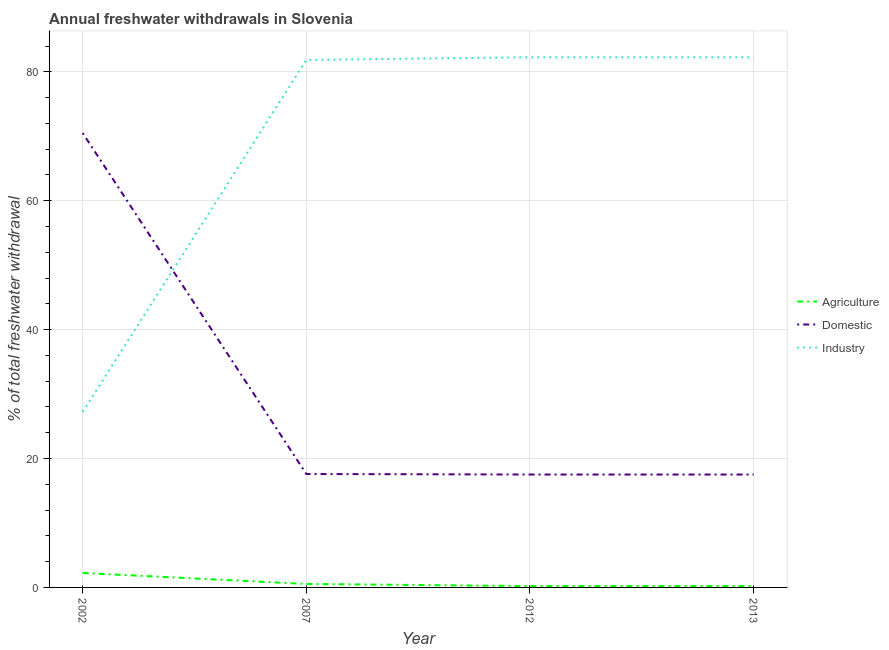Does the line corresponding to percentage of freshwater withdrawal for domestic purposes intersect with the line corresponding to percentage of freshwater withdrawal for industry?
Ensure brevity in your answer.  Yes. Is the number of lines equal to the number of legend labels?
Keep it short and to the point. Yes. What is the percentage of freshwater withdrawal for industry in 2007?
Ensure brevity in your answer.  81.86. Across all years, what is the maximum percentage of freshwater withdrawal for agriculture?
Make the answer very short. 2.24. Across all years, what is the minimum percentage of freshwater withdrawal for industry?
Keep it short and to the point. 27.24. In which year was the percentage of freshwater withdrawal for industry maximum?
Your answer should be very brief. 2012. In which year was the percentage of freshwater withdrawal for agriculture minimum?
Offer a very short reply. 2012. What is the total percentage of freshwater withdrawal for agriculture in the graph?
Your answer should be compact. 3.21. What is the difference between the percentage of freshwater withdrawal for agriculture in 2002 and that in 2013?
Your response must be concise. 2.03. What is the difference between the percentage of freshwater withdrawal for agriculture in 2012 and the percentage of freshwater withdrawal for domestic purposes in 2007?
Give a very brief answer. -17.39. What is the average percentage of freshwater withdrawal for industry per year?
Your response must be concise. 68.41. In the year 2012, what is the difference between the percentage of freshwater withdrawal for agriculture and percentage of freshwater withdrawal for domestic purposes?
Provide a short and direct response. -17.31. What is the ratio of the percentage of freshwater withdrawal for domestic purposes in 2002 to that in 2013?
Offer a very short reply. 4.02. Is the percentage of freshwater withdrawal for industry in 2007 less than that in 2012?
Your answer should be very brief. Yes. Is the difference between the percentage of freshwater withdrawal for domestic purposes in 2002 and 2007 greater than the difference between the percentage of freshwater withdrawal for agriculture in 2002 and 2007?
Your answer should be compact. Yes. What is the difference between the highest and the second highest percentage of freshwater withdrawal for industry?
Offer a terse response. 0. What is the difference between the highest and the lowest percentage of freshwater withdrawal for agriculture?
Offer a very short reply. 2.03. Is the percentage of freshwater withdrawal for agriculture strictly less than the percentage of freshwater withdrawal for domestic purposes over the years?
Your answer should be compact. Yes. How many lines are there?
Give a very brief answer. 3. How many years are there in the graph?
Offer a very short reply. 4. Are the values on the major ticks of Y-axis written in scientific E-notation?
Your answer should be compact. No. Where does the legend appear in the graph?
Offer a very short reply. Center right. How are the legend labels stacked?
Keep it short and to the point. Vertical. What is the title of the graph?
Your answer should be compact. Annual freshwater withdrawals in Slovenia. Does "Poland" appear as one of the legend labels in the graph?
Ensure brevity in your answer.  No. What is the label or title of the Y-axis?
Ensure brevity in your answer.  % of total freshwater withdrawal. What is the % of total freshwater withdrawal of Agriculture in 2002?
Your answer should be compact. 2.24. What is the % of total freshwater withdrawal in Domestic in 2002?
Your answer should be compact. 70.51. What is the % of total freshwater withdrawal in Industry in 2002?
Ensure brevity in your answer.  27.24. What is the % of total freshwater withdrawal in Agriculture in 2007?
Give a very brief answer. 0.54. What is the % of total freshwater withdrawal of Industry in 2007?
Ensure brevity in your answer.  81.86. What is the % of total freshwater withdrawal in Agriculture in 2012?
Provide a short and direct response. 0.21. What is the % of total freshwater withdrawal in Domestic in 2012?
Your answer should be compact. 17.52. What is the % of total freshwater withdrawal in Industry in 2012?
Provide a short and direct response. 82.27. What is the % of total freshwater withdrawal of Agriculture in 2013?
Provide a short and direct response. 0.21. What is the % of total freshwater withdrawal of Domestic in 2013?
Offer a very short reply. 17.52. What is the % of total freshwater withdrawal of Industry in 2013?
Your response must be concise. 82.27. Across all years, what is the maximum % of total freshwater withdrawal in Agriculture?
Keep it short and to the point. 2.24. Across all years, what is the maximum % of total freshwater withdrawal in Domestic?
Your answer should be very brief. 70.51. Across all years, what is the maximum % of total freshwater withdrawal of Industry?
Your answer should be very brief. 82.27. Across all years, what is the minimum % of total freshwater withdrawal in Agriculture?
Make the answer very short. 0.21. Across all years, what is the minimum % of total freshwater withdrawal in Domestic?
Ensure brevity in your answer.  17.52. Across all years, what is the minimum % of total freshwater withdrawal of Industry?
Provide a succinct answer. 27.24. What is the total % of total freshwater withdrawal in Agriculture in the graph?
Your answer should be very brief. 3.21. What is the total % of total freshwater withdrawal of Domestic in the graph?
Ensure brevity in your answer.  123.15. What is the total % of total freshwater withdrawal of Industry in the graph?
Offer a terse response. 273.64. What is the difference between the % of total freshwater withdrawal in Agriculture in 2002 and that in 2007?
Offer a terse response. 1.7. What is the difference between the % of total freshwater withdrawal of Domestic in 2002 and that in 2007?
Provide a succinct answer. 52.91. What is the difference between the % of total freshwater withdrawal in Industry in 2002 and that in 2007?
Ensure brevity in your answer.  -54.62. What is the difference between the % of total freshwater withdrawal in Agriculture in 2002 and that in 2012?
Ensure brevity in your answer.  2.03. What is the difference between the % of total freshwater withdrawal in Domestic in 2002 and that in 2012?
Your answer should be compact. 52.99. What is the difference between the % of total freshwater withdrawal in Industry in 2002 and that in 2012?
Your response must be concise. -55.03. What is the difference between the % of total freshwater withdrawal of Agriculture in 2002 and that in 2013?
Give a very brief answer. 2.03. What is the difference between the % of total freshwater withdrawal in Domestic in 2002 and that in 2013?
Keep it short and to the point. 52.99. What is the difference between the % of total freshwater withdrawal of Industry in 2002 and that in 2013?
Provide a short and direct response. -55.03. What is the difference between the % of total freshwater withdrawal of Agriculture in 2007 and that in 2012?
Offer a terse response. 0.33. What is the difference between the % of total freshwater withdrawal of Domestic in 2007 and that in 2012?
Your response must be concise. 0.08. What is the difference between the % of total freshwater withdrawal in Industry in 2007 and that in 2012?
Provide a short and direct response. -0.41. What is the difference between the % of total freshwater withdrawal in Agriculture in 2007 and that in 2013?
Give a very brief answer. 0.33. What is the difference between the % of total freshwater withdrawal in Industry in 2007 and that in 2013?
Ensure brevity in your answer.  -0.41. What is the difference between the % of total freshwater withdrawal in Industry in 2012 and that in 2013?
Your answer should be very brief. 0. What is the difference between the % of total freshwater withdrawal in Agriculture in 2002 and the % of total freshwater withdrawal in Domestic in 2007?
Provide a succinct answer. -15.36. What is the difference between the % of total freshwater withdrawal of Agriculture in 2002 and the % of total freshwater withdrawal of Industry in 2007?
Make the answer very short. -79.62. What is the difference between the % of total freshwater withdrawal in Domestic in 2002 and the % of total freshwater withdrawal in Industry in 2007?
Give a very brief answer. -11.35. What is the difference between the % of total freshwater withdrawal of Agriculture in 2002 and the % of total freshwater withdrawal of Domestic in 2012?
Keep it short and to the point. -15.28. What is the difference between the % of total freshwater withdrawal of Agriculture in 2002 and the % of total freshwater withdrawal of Industry in 2012?
Provide a succinct answer. -80.03. What is the difference between the % of total freshwater withdrawal of Domestic in 2002 and the % of total freshwater withdrawal of Industry in 2012?
Ensure brevity in your answer.  -11.76. What is the difference between the % of total freshwater withdrawal of Agriculture in 2002 and the % of total freshwater withdrawal of Domestic in 2013?
Your answer should be very brief. -15.28. What is the difference between the % of total freshwater withdrawal of Agriculture in 2002 and the % of total freshwater withdrawal of Industry in 2013?
Provide a succinct answer. -80.03. What is the difference between the % of total freshwater withdrawal of Domestic in 2002 and the % of total freshwater withdrawal of Industry in 2013?
Your response must be concise. -11.76. What is the difference between the % of total freshwater withdrawal in Agriculture in 2007 and the % of total freshwater withdrawal in Domestic in 2012?
Make the answer very short. -16.98. What is the difference between the % of total freshwater withdrawal of Agriculture in 2007 and the % of total freshwater withdrawal of Industry in 2012?
Ensure brevity in your answer.  -81.73. What is the difference between the % of total freshwater withdrawal of Domestic in 2007 and the % of total freshwater withdrawal of Industry in 2012?
Your response must be concise. -64.67. What is the difference between the % of total freshwater withdrawal of Agriculture in 2007 and the % of total freshwater withdrawal of Domestic in 2013?
Keep it short and to the point. -16.98. What is the difference between the % of total freshwater withdrawal in Agriculture in 2007 and the % of total freshwater withdrawal in Industry in 2013?
Provide a succinct answer. -81.73. What is the difference between the % of total freshwater withdrawal of Domestic in 2007 and the % of total freshwater withdrawal of Industry in 2013?
Your answer should be very brief. -64.67. What is the difference between the % of total freshwater withdrawal of Agriculture in 2012 and the % of total freshwater withdrawal of Domestic in 2013?
Provide a succinct answer. -17.31. What is the difference between the % of total freshwater withdrawal in Agriculture in 2012 and the % of total freshwater withdrawal in Industry in 2013?
Give a very brief answer. -82.06. What is the difference between the % of total freshwater withdrawal of Domestic in 2012 and the % of total freshwater withdrawal of Industry in 2013?
Your answer should be very brief. -64.75. What is the average % of total freshwater withdrawal of Agriculture per year?
Provide a short and direct response. 0.8. What is the average % of total freshwater withdrawal in Domestic per year?
Keep it short and to the point. 30.79. What is the average % of total freshwater withdrawal in Industry per year?
Give a very brief answer. 68.41. In the year 2002, what is the difference between the % of total freshwater withdrawal of Agriculture and % of total freshwater withdrawal of Domestic?
Offer a terse response. -68.27. In the year 2002, what is the difference between the % of total freshwater withdrawal of Agriculture and % of total freshwater withdrawal of Industry?
Make the answer very short. -25. In the year 2002, what is the difference between the % of total freshwater withdrawal in Domestic and % of total freshwater withdrawal in Industry?
Your answer should be very brief. 43.27. In the year 2007, what is the difference between the % of total freshwater withdrawal of Agriculture and % of total freshwater withdrawal of Domestic?
Ensure brevity in your answer.  -17.06. In the year 2007, what is the difference between the % of total freshwater withdrawal in Agriculture and % of total freshwater withdrawal in Industry?
Offer a terse response. -81.32. In the year 2007, what is the difference between the % of total freshwater withdrawal in Domestic and % of total freshwater withdrawal in Industry?
Provide a succinct answer. -64.26. In the year 2012, what is the difference between the % of total freshwater withdrawal of Agriculture and % of total freshwater withdrawal of Domestic?
Provide a short and direct response. -17.31. In the year 2012, what is the difference between the % of total freshwater withdrawal of Agriculture and % of total freshwater withdrawal of Industry?
Provide a succinct answer. -82.06. In the year 2012, what is the difference between the % of total freshwater withdrawal in Domestic and % of total freshwater withdrawal in Industry?
Give a very brief answer. -64.75. In the year 2013, what is the difference between the % of total freshwater withdrawal of Agriculture and % of total freshwater withdrawal of Domestic?
Offer a terse response. -17.31. In the year 2013, what is the difference between the % of total freshwater withdrawal of Agriculture and % of total freshwater withdrawal of Industry?
Your answer should be compact. -82.06. In the year 2013, what is the difference between the % of total freshwater withdrawal in Domestic and % of total freshwater withdrawal in Industry?
Your answer should be compact. -64.75. What is the ratio of the % of total freshwater withdrawal of Agriculture in 2002 to that in 2007?
Offer a terse response. 4.16. What is the ratio of the % of total freshwater withdrawal in Domestic in 2002 to that in 2007?
Offer a terse response. 4.01. What is the ratio of the % of total freshwater withdrawal in Industry in 2002 to that in 2007?
Your answer should be compact. 0.33. What is the ratio of the % of total freshwater withdrawal in Agriculture in 2002 to that in 2012?
Offer a very short reply. 10.57. What is the ratio of the % of total freshwater withdrawal of Domestic in 2002 to that in 2012?
Your response must be concise. 4.02. What is the ratio of the % of total freshwater withdrawal of Industry in 2002 to that in 2012?
Your response must be concise. 0.33. What is the ratio of the % of total freshwater withdrawal of Agriculture in 2002 to that in 2013?
Ensure brevity in your answer.  10.57. What is the ratio of the % of total freshwater withdrawal of Domestic in 2002 to that in 2013?
Offer a terse response. 4.02. What is the ratio of the % of total freshwater withdrawal in Industry in 2002 to that in 2013?
Give a very brief answer. 0.33. What is the ratio of the % of total freshwater withdrawal in Agriculture in 2007 to that in 2012?
Your answer should be compact. 2.54. What is the ratio of the % of total freshwater withdrawal of Agriculture in 2007 to that in 2013?
Provide a short and direct response. 2.54. What is the ratio of the % of total freshwater withdrawal in Domestic in 2007 to that in 2013?
Your answer should be compact. 1. What is the ratio of the % of total freshwater withdrawal of Domestic in 2012 to that in 2013?
Make the answer very short. 1. What is the ratio of the % of total freshwater withdrawal in Industry in 2012 to that in 2013?
Provide a short and direct response. 1. What is the difference between the highest and the second highest % of total freshwater withdrawal in Agriculture?
Provide a succinct answer. 1.7. What is the difference between the highest and the second highest % of total freshwater withdrawal of Domestic?
Your answer should be very brief. 52.91. What is the difference between the highest and the second highest % of total freshwater withdrawal of Industry?
Ensure brevity in your answer.  0. What is the difference between the highest and the lowest % of total freshwater withdrawal of Agriculture?
Your answer should be compact. 2.03. What is the difference between the highest and the lowest % of total freshwater withdrawal of Domestic?
Your answer should be very brief. 52.99. What is the difference between the highest and the lowest % of total freshwater withdrawal of Industry?
Your response must be concise. 55.03. 